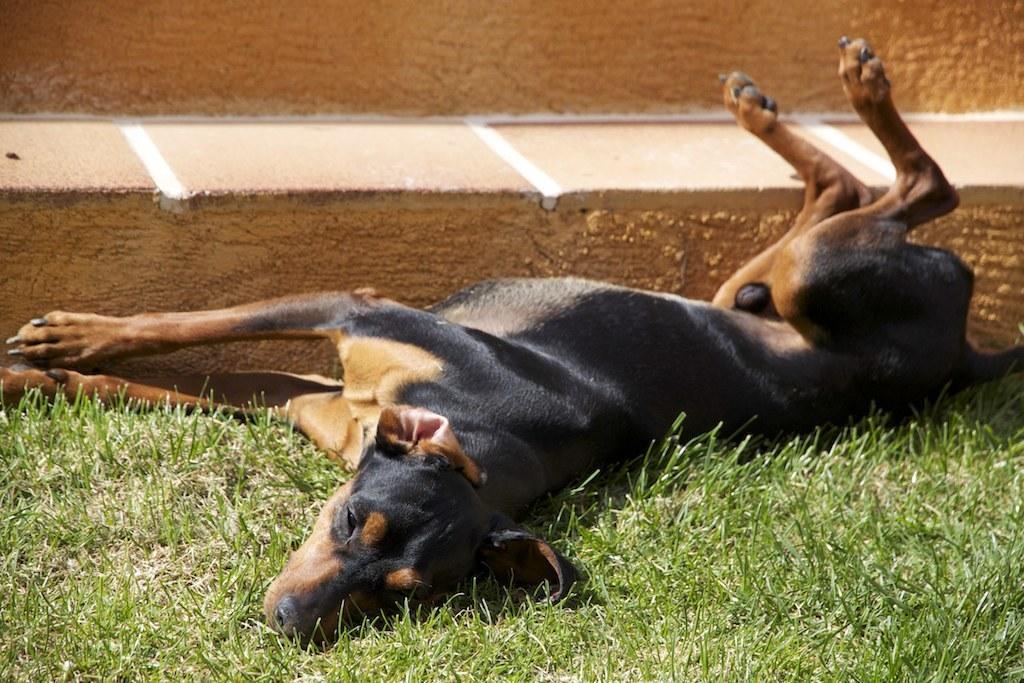In one or two sentences, can you explain what this image depicts? In this picture there is a dog and we can see grass and ground. 